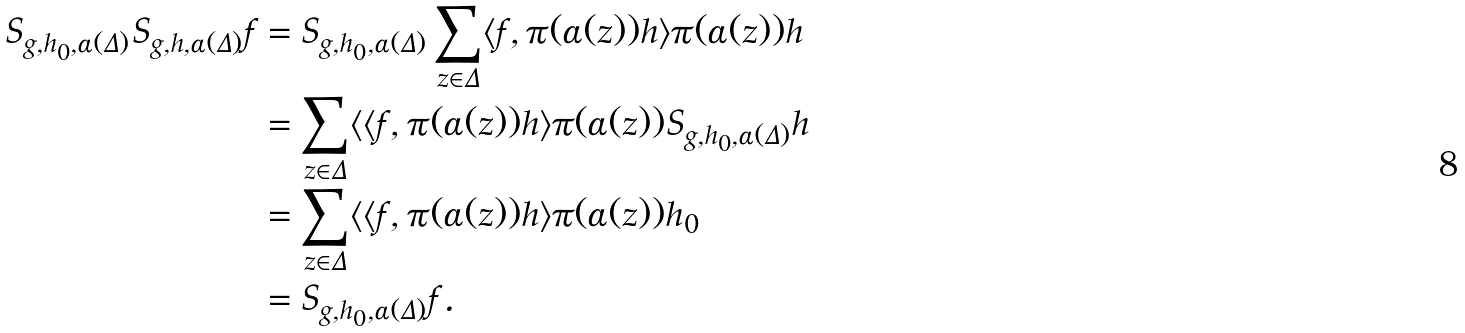Convert formula to latex. <formula><loc_0><loc_0><loc_500><loc_500>S _ { g , h _ { 0 } , \alpha ( \Delta ) } S _ { g , h , \alpha ( \Delta ) } f & = S _ { g , h _ { 0 } , \alpha ( \Delta ) } \sum _ { z \in \Delta } \langle f , \pi ( \alpha ( z ) ) h \rangle \pi ( \alpha ( z ) ) h \\ & = \sum _ { z \in \Delta } \langle \langle f , \pi ( \alpha ( z ) ) h \rangle \pi ( \alpha ( z ) ) S _ { g , h _ { 0 } , \alpha ( \Delta ) } h \\ & = \sum _ { z \in \Delta } \langle \langle f , \pi ( \alpha ( z ) ) h \rangle \pi ( \alpha ( z ) ) h _ { 0 } \\ & = S _ { g , h _ { 0 } , \alpha ( \Delta ) } f .</formula> 